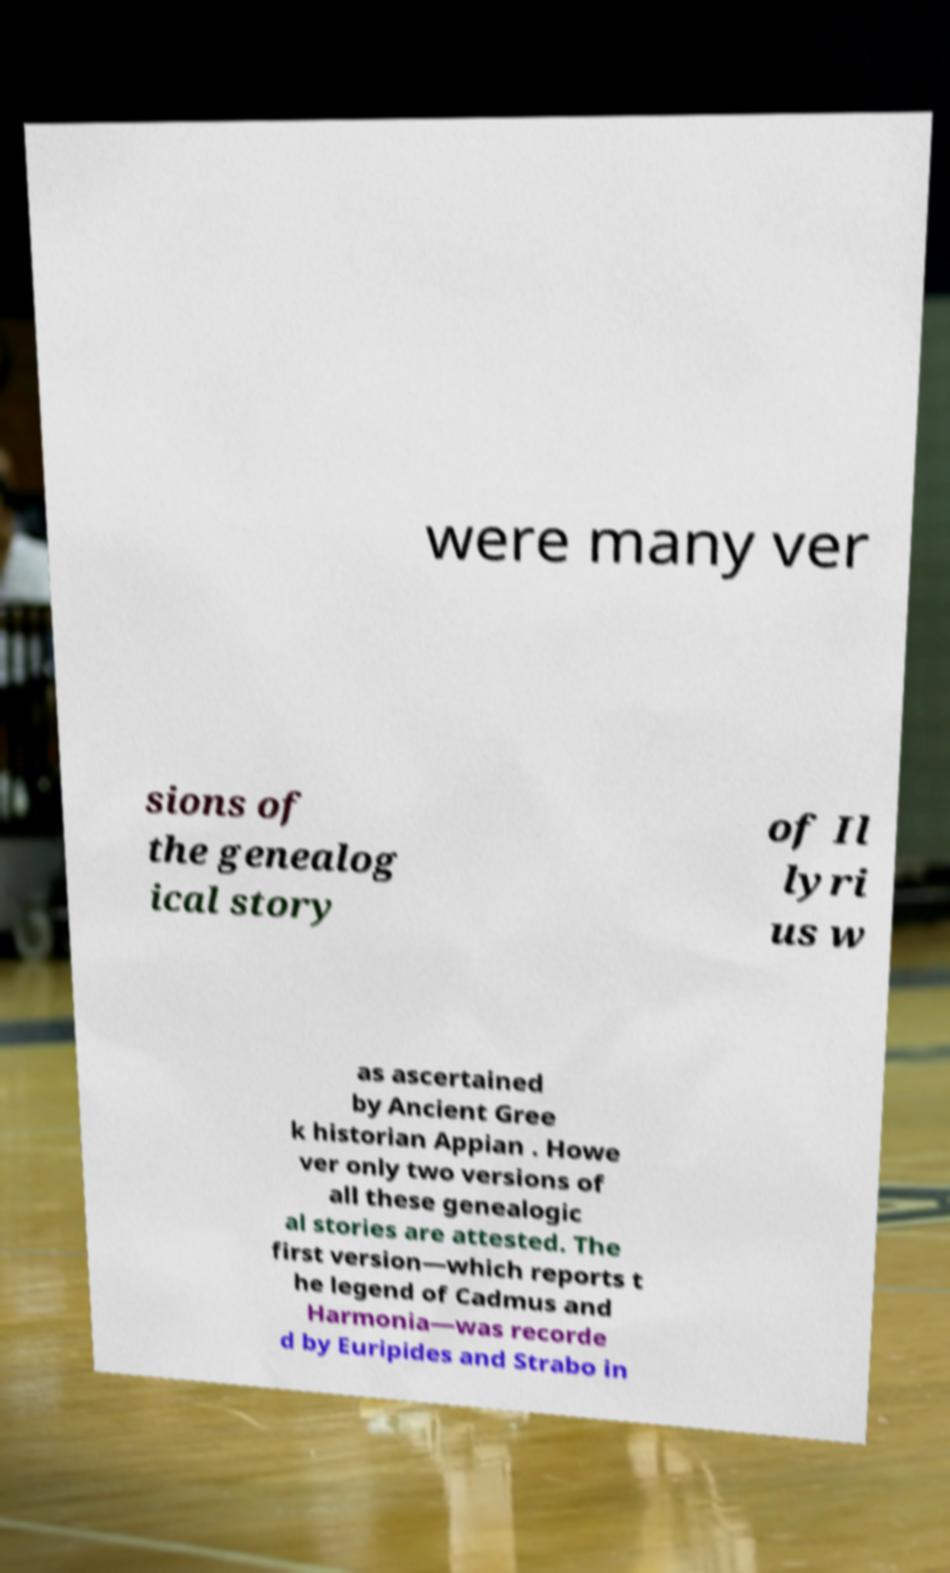There's text embedded in this image that I need extracted. Can you transcribe it verbatim? were many ver sions of the genealog ical story of Il lyri us w as ascertained by Ancient Gree k historian Appian . Howe ver only two versions of all these genealogic al stories are attested. The first version—which reports t he legend of Cadmus and Harmonia—was recorde d by Euripides and Strabo in 